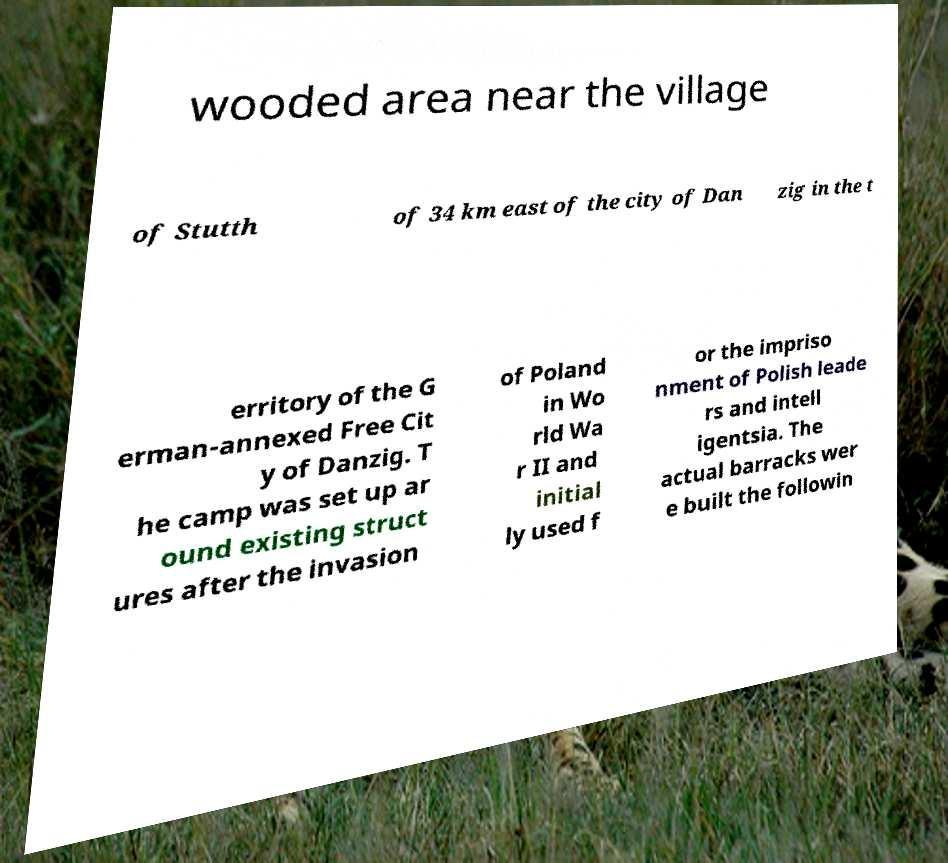Can you accurately transcribe the text from the provided image for me? wooded area near the village of Stutth of 34 km east of the city of Dan zig in the t erritory of the G erman-annexed Free Cit y of Danzig. T he camp was set up ar ound existing struct ures after the invasion of Poland in Wo rld Wa r II and initial ly used f or the impriso nment of Polish leade rs and intell igentsia. The actual barracks wer e built the followin 